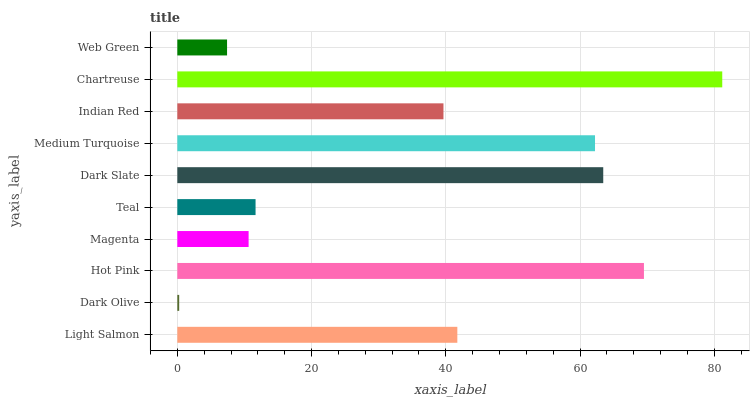Is Dark Olive the minimum?
Answer yes or no. Yes. Is Chartreuse the maximum?
Answer yes or no. Yes. Is Hot Pink the minimum?
Answer yes or no. No. Is Hot Pink the maximum?
Answer yes or no. No. Is Hot Pink greater than Dark Olive?
Answer yes or no. Yes. Is Dark Olive less than Hot Pink?
Answer yes or no. Yes. Is Dark Olive greater than Hot Pink?
Answer yes or no. No. Is Hot Pink less than Dark Olive?
Answer yes or no. No. Is Light Salmon the high median?
Answer yes or no. Yes. Is Indian Red the low median?
Answer yes or no. Yes. Is Chartreuse the high median?
Answer yes or no. No. Is Light Salmon the low median?
Answer yes or no. No. 